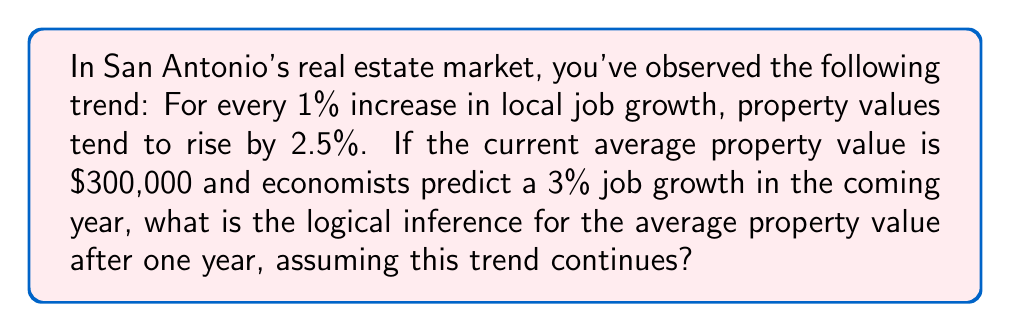Solve this math problem. Let's approach this step-by-step using logical inference:

1) First, we need to establish the relationship between job growth and property value increase:
   - 1% job growth corresponds to 2.5% property value increase

2) We're given that the predicted job growth is 3%. To find the corresponding property value increase, we can set up a proportion:
   
   $\frac{1\%}{2.5\%} = \frac{3\%}{x\%}$

3) Cross-multiplying:
   
   $1 \cdot x = 2.5 \cdot 3$

4) Solving for x:
   
   $x = \frac{2.5 \cdot 3}{1} = 7.5\%$

5) So, a 3% job growth logically corresponds to a 7.5% increase in property value.

6) Now, let's calculate the new property value:
   - Current value: $300,000
   - Increase: 7.5% of $300,000 = $300,000 \cdot 0.075 = $22,500

7) Therefore, the new property value would be:
   
   $300,000 + 22,500 = $322,500

This logical inference assumes that the observed trend continues and that no other significant factors affect property values during this period.
Answer: $322,500 